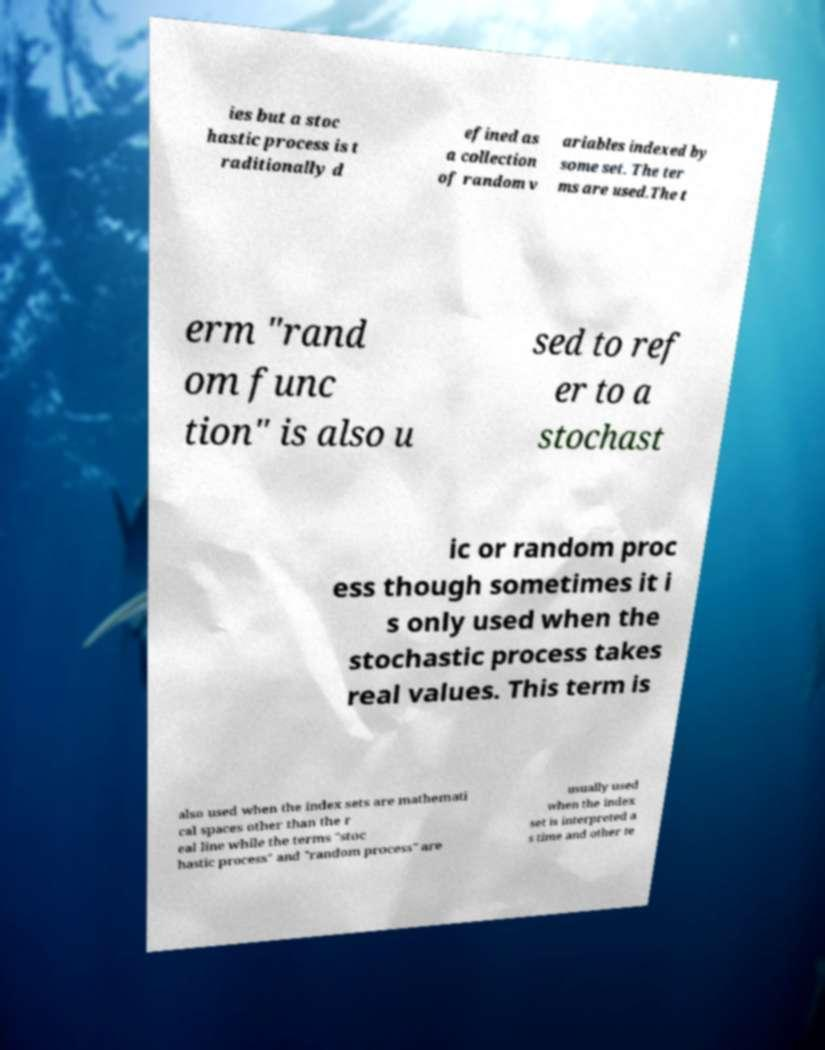Please identify and transcribe the text found in this image. ies but a stoc hastic process is t raditionally d efined as a collection of random v ariables indexed by some set. The ter ms are used.The t erm "rand om func tion" is also u sed to ref er to a stochast ic or random proc ess though sometimes it i s only used when the stochastic process takes real values. This term is also used when the index sets are mathemati cal spaces other than the r eal line while the terms "stoc hastic process" and "random process" are usually used when the index set is interpreted a s time and other te 